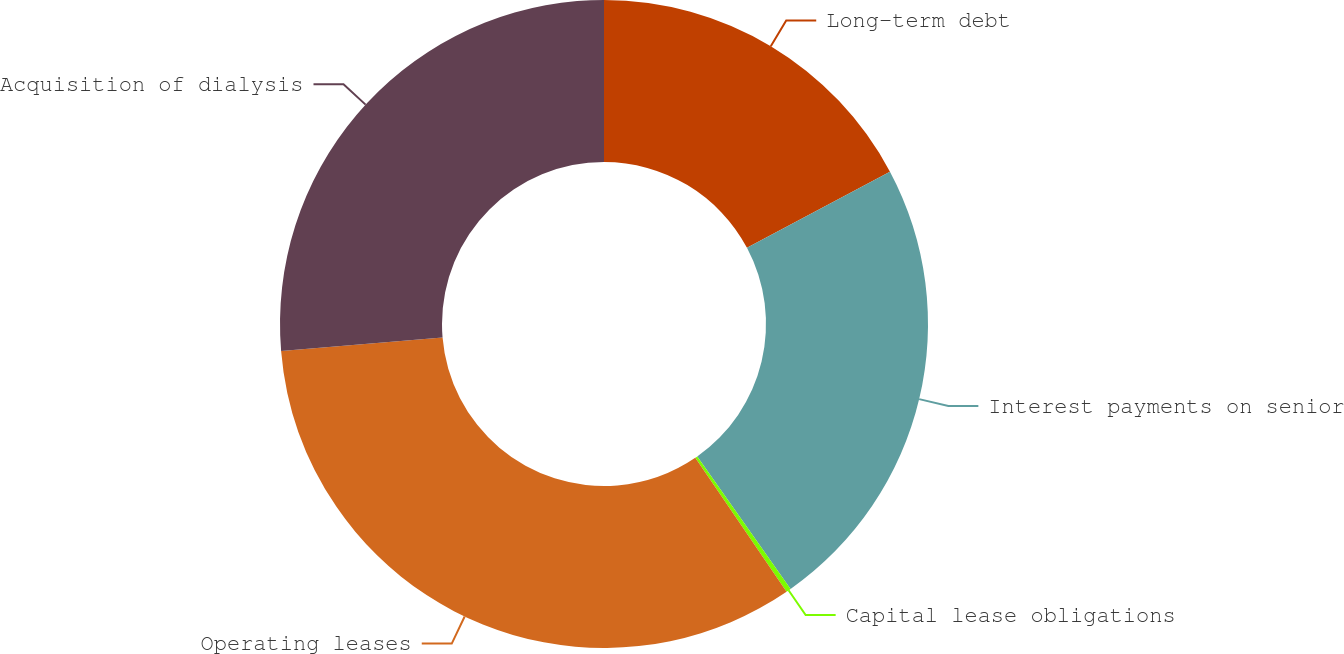Convert chart to OTSL. <chart><loc_0><loc_0><loc_500><loc_500><pie_chart><fcel>Long-term debt<fcel>Interest payments on senior<fcel>Capital lease obligations<fcel>Operating leases<fcel>Acquisition of dialysis<nl><fcel>17.21%<fcel>23.02%<fcel>0.24%<fcel>33.2%<fcel>26.32%<nl></chart> 